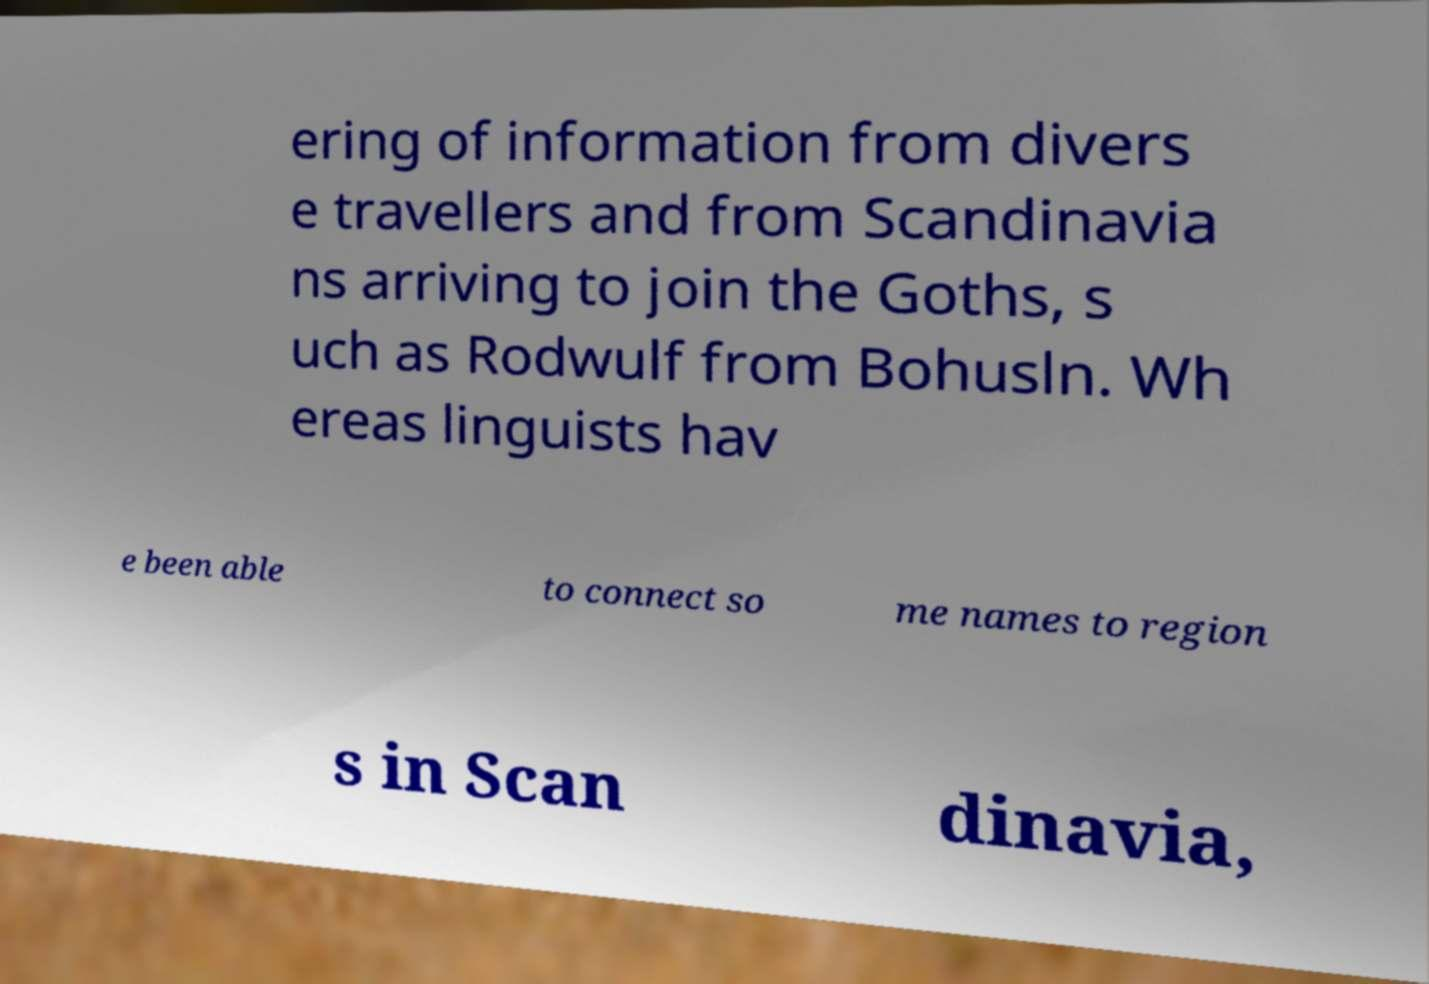What messages or text are displayed in this image? I need them in a readable, typed format. ering of information from divers e travellers and from Scandinavia ns arriving to join the Goths, s uch as Rodwulf from Bohusln. Wh ereas linguists hav e been able to connect so me names to region s in Scan dinavia, 